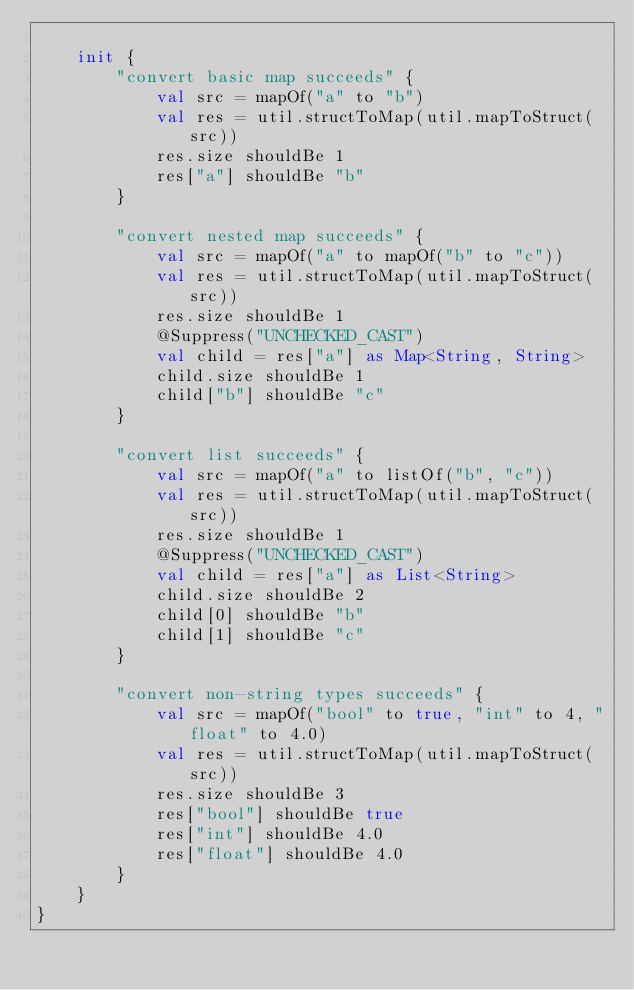Convert code to text. <code><loc_0><loc_0><loc_500><loc_500><_Kotlin_>
    init {
        "convert basic map succeeds" {
            val src = mapOf("a" to "b")
            val res = util.structToMap(util.mapToStruct(src))
            res.size shouldBe 1
            res["a"] shouldBe "b"
        }

        "convert nested map succeeds" {
            val src = mapOf("a" to mapOf("b" to "c"))
            val res = util.structToMap(util.mapToStruct(src))
            res.size shouldBe 1
            @Suppress("UNCHECKED_CAST")
            val child = res["a"] as Map<String, String>
            child.size shouldBe 1
            child["b"] shouldBe "c"
        }

        "convert list succeeds" {
            val src = mapOf("a" to listOf("b", "c"))
            val res = util.structToMap(util.mapToStruct(src))
            res.size shouldBe 1
            @Suppress("UNCHECKED_CAST")
            val child = res["a"] as List<String>
            child.size shouldBe 2
            child[0] shouldBe "b"
            child[1] shouldBe "c"
        }

        "convert non-string types succeeds" {
            val src = mapOf("bool" to true, "int" to 4, "float" to 4.0)
            val res = util.structToMap(util.mapToStruct(src))
            res.size shouldBe 3
            res["bool"] shouldBe true
            res["int"] shouldBe 4.0
            res["float"] shouldBe 4.0
        }
    }
}
</code> 